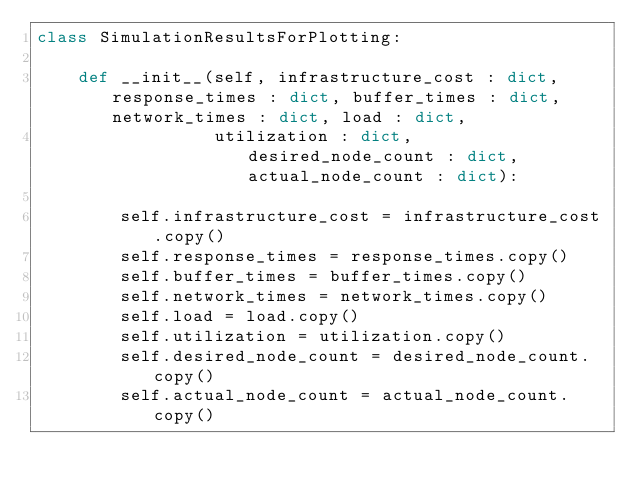<code> <loc_0><loc_0><loc_500><loc_500><_Python_>class SimulationResultsForPlotting:

    def __init__(self, infrastructure_cost : dict, response_times : dict, buffer_times : dict, network_times : dict, load : dict,
                 utilization : dict, desired_node_count : dict, actual_node_count : dict):

        self.infrastructure_cost = infrastructure_cost.copy()
        self.response_times = response_times.copy()
        self.buffer_times = buffer_times.copy()
        self.network_times = network_times.copy()
        self.load = load.copy()
        self.utilization = utilization.copy()
        self.desired_node_count = desired_node_count.copy()
        self.actual_node_count = actual_node_count.copy()
</code> 